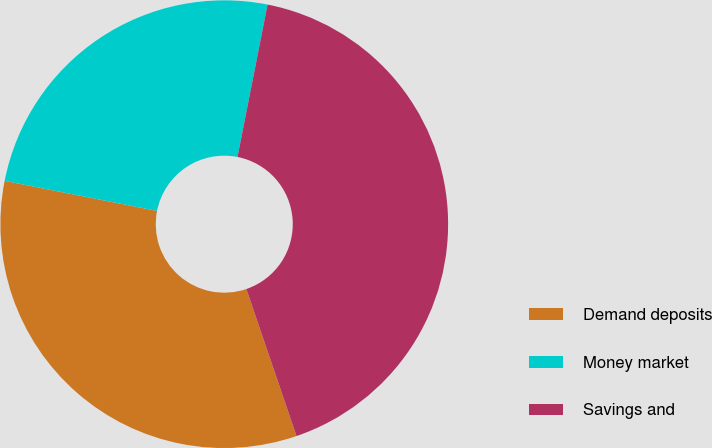Convert chart to OTSL. <chart><loc_0><loc_0><loc_500><loc_500><pie_chart><fcel>Demand deposits<fcel>Money market<fcel>Savings and<nl><fcel>33.33%<fcel>25.0%<fcel>41.67%<nl></chart> 